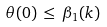Convert formula to latex. <formula><loc_0><loc_0><loc_500><loc_500>\theta ( 0 ) \, \leq \, \beta _ { 1 } ( k ) \,</formula> 